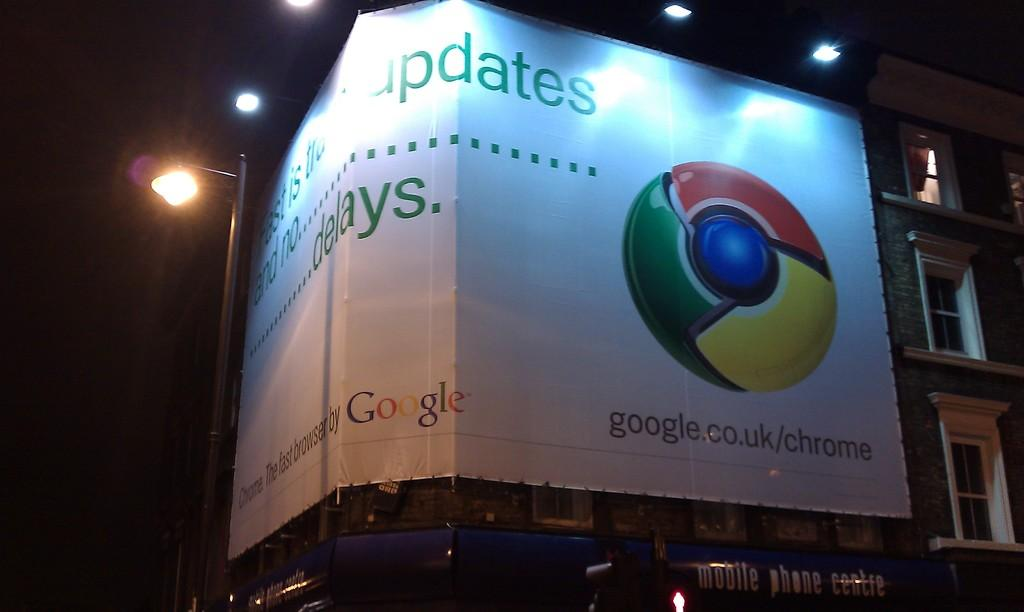<image>
Share a concise interpretation of the image provided. A banner for google wraps around the corner of a building. 